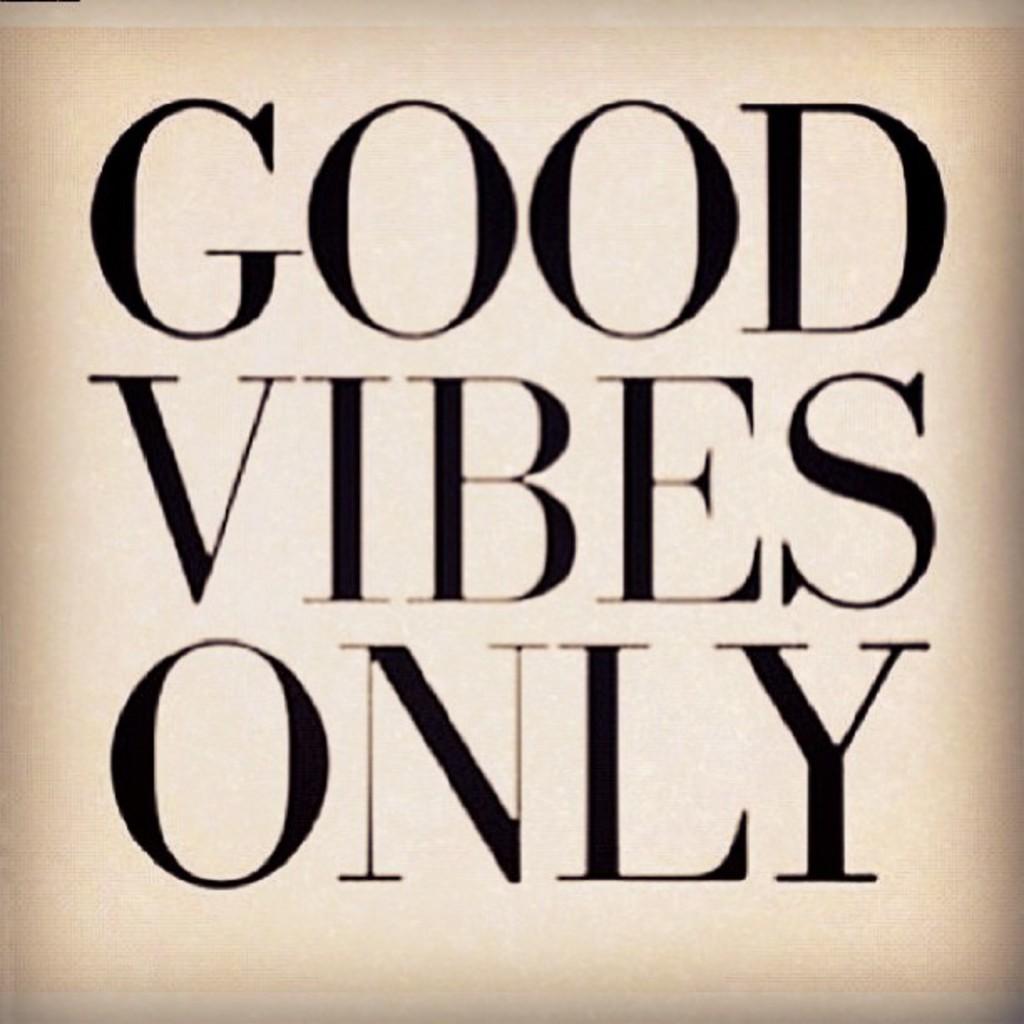What kind of vibes should their only be?
Offer a terse response. Good. What does the first word say?
Your response must be concise. Good. 